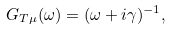Convert formula to latex. <formula><loc_0><loc_0><loc_500><loc_500>G _ { T \mu } ( \omega ) = ( \omega + i \gamma ) ^ { - 1 } ,</formula> 